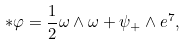Convert formula to latex. <formula><loc_0><loc_0><loc_500><loc_500>\ast \varphi = \frac { 1 } { 2 } \omega \wedge \omega + \psi _ { + } \wedge e ^ { 7 } ,</formula> 